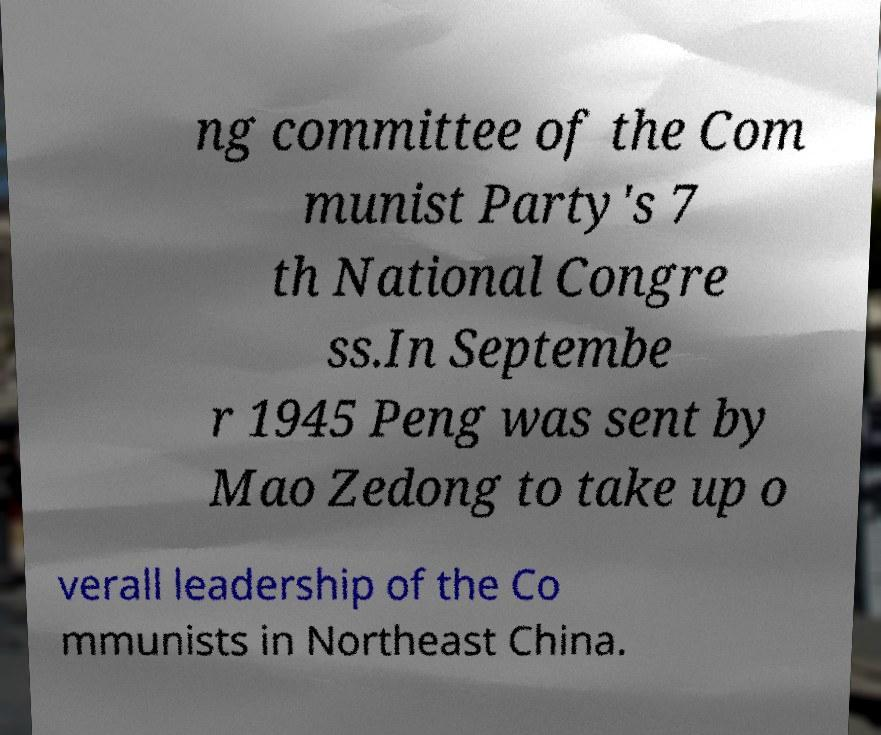There's text embedded in this image that I need extracted. Can you transcribe it verbatim? ng committee of the Com munist Party's 7 th National Congre ss.In Septembe r 1945 Peng was sent by Mao Zedong to take up o verall leadership of the Co mmunists in Northeast China. 